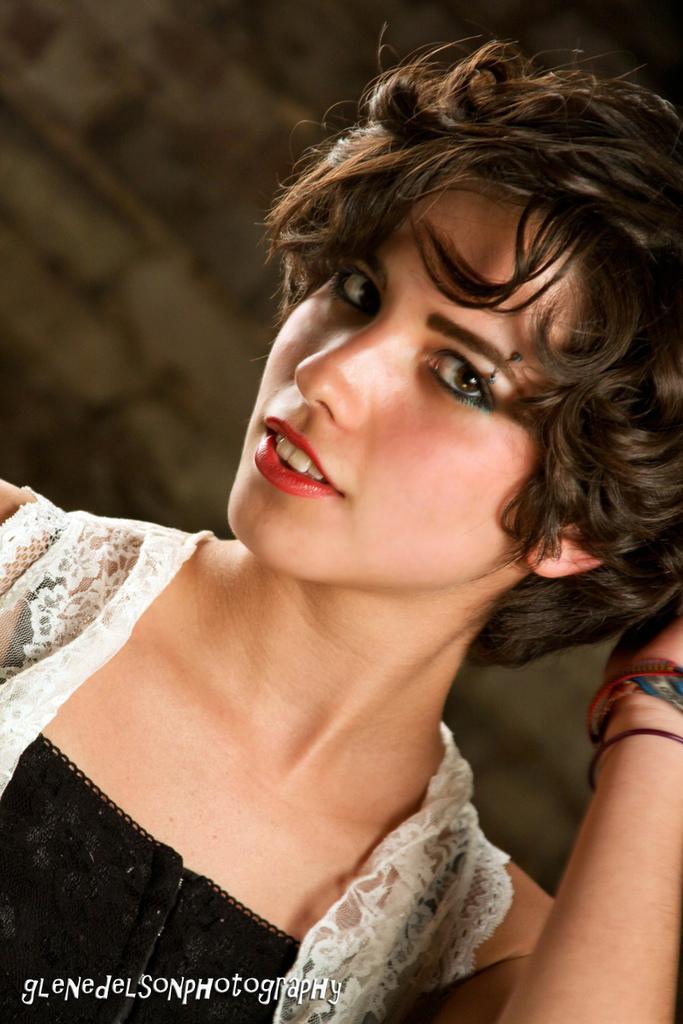Describe this image in one or two sentences. In this image there is a woman, at the bottom of the image there is some text. 